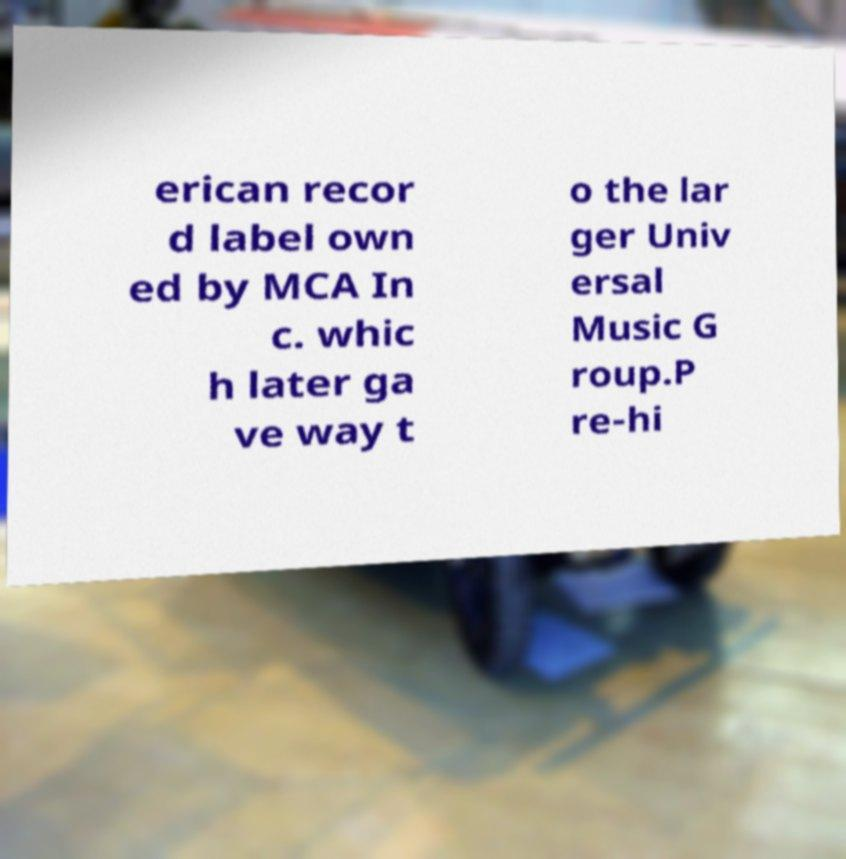There's text embedded in this image that I need extracted. Can you transcribe it verbatim? erican recor d label own ed by MCA In c. whic h later ga ve way t o the lar ger Univ ersal Music G roup.P re-hi 